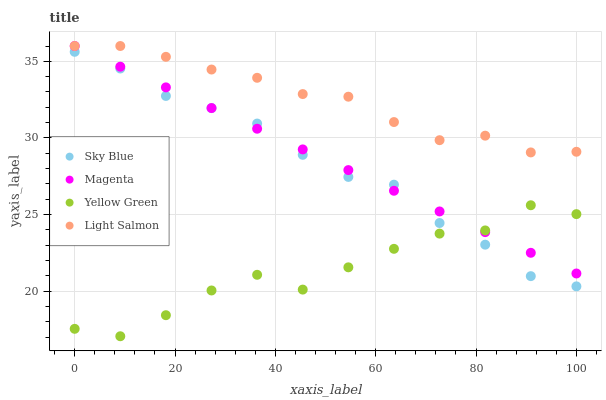Does Yellow Green have the minimum area under the curve?
Answer yes or no. Yes. Does Light Salmon have the maximum area under the curve?
Answer yes or no. Yes. Does Magenta have the minimum area under the curve?
Answer yes or no. No. Does Magenta have the maximum area under the curve?
Answer yes or no. No. Is Magenta the smoothest?
Answer yes or no. Yes. Is Yellow Green the roughest?
Answer yes or no. Yes. Is Yellow Green the smoothest?
Answer yes or no. No. Is Magenta the roughest?
Answer yes or no. No. Does Yellow Green have the lowest value?
Answer yes or no. Yes. Does Magenta have the lowest value?
Answer yes or no. No. Does Light Salmon have the highest value?
Answer yes or no. Yes. Does Yellow Green have the highest value?
Answer yes or no. No. Is Yellow Green less than Light Salmon?
Answer yes or no. Yes. Is Light Salmon greater than Yellow Green?
Answer yes or no. Yes. Does Magenta intersect Light Salmon?
Answer yes or no. Yes. Is Magenta less than Light Salmon?
Answer yes or no. No. Is Magenta greater than Light Salmon?
Answer yes or no. No. Does Yellow Green intersect Light Salmon?
Answer yes or no. No. 